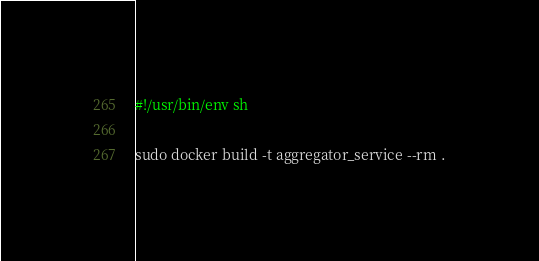<code> <loc_0><loc_0><loc_500><loc_500><_Bash_>#!/usr/bin/env sh

sudo docker build -t aggregator_service --rm .
</code> 